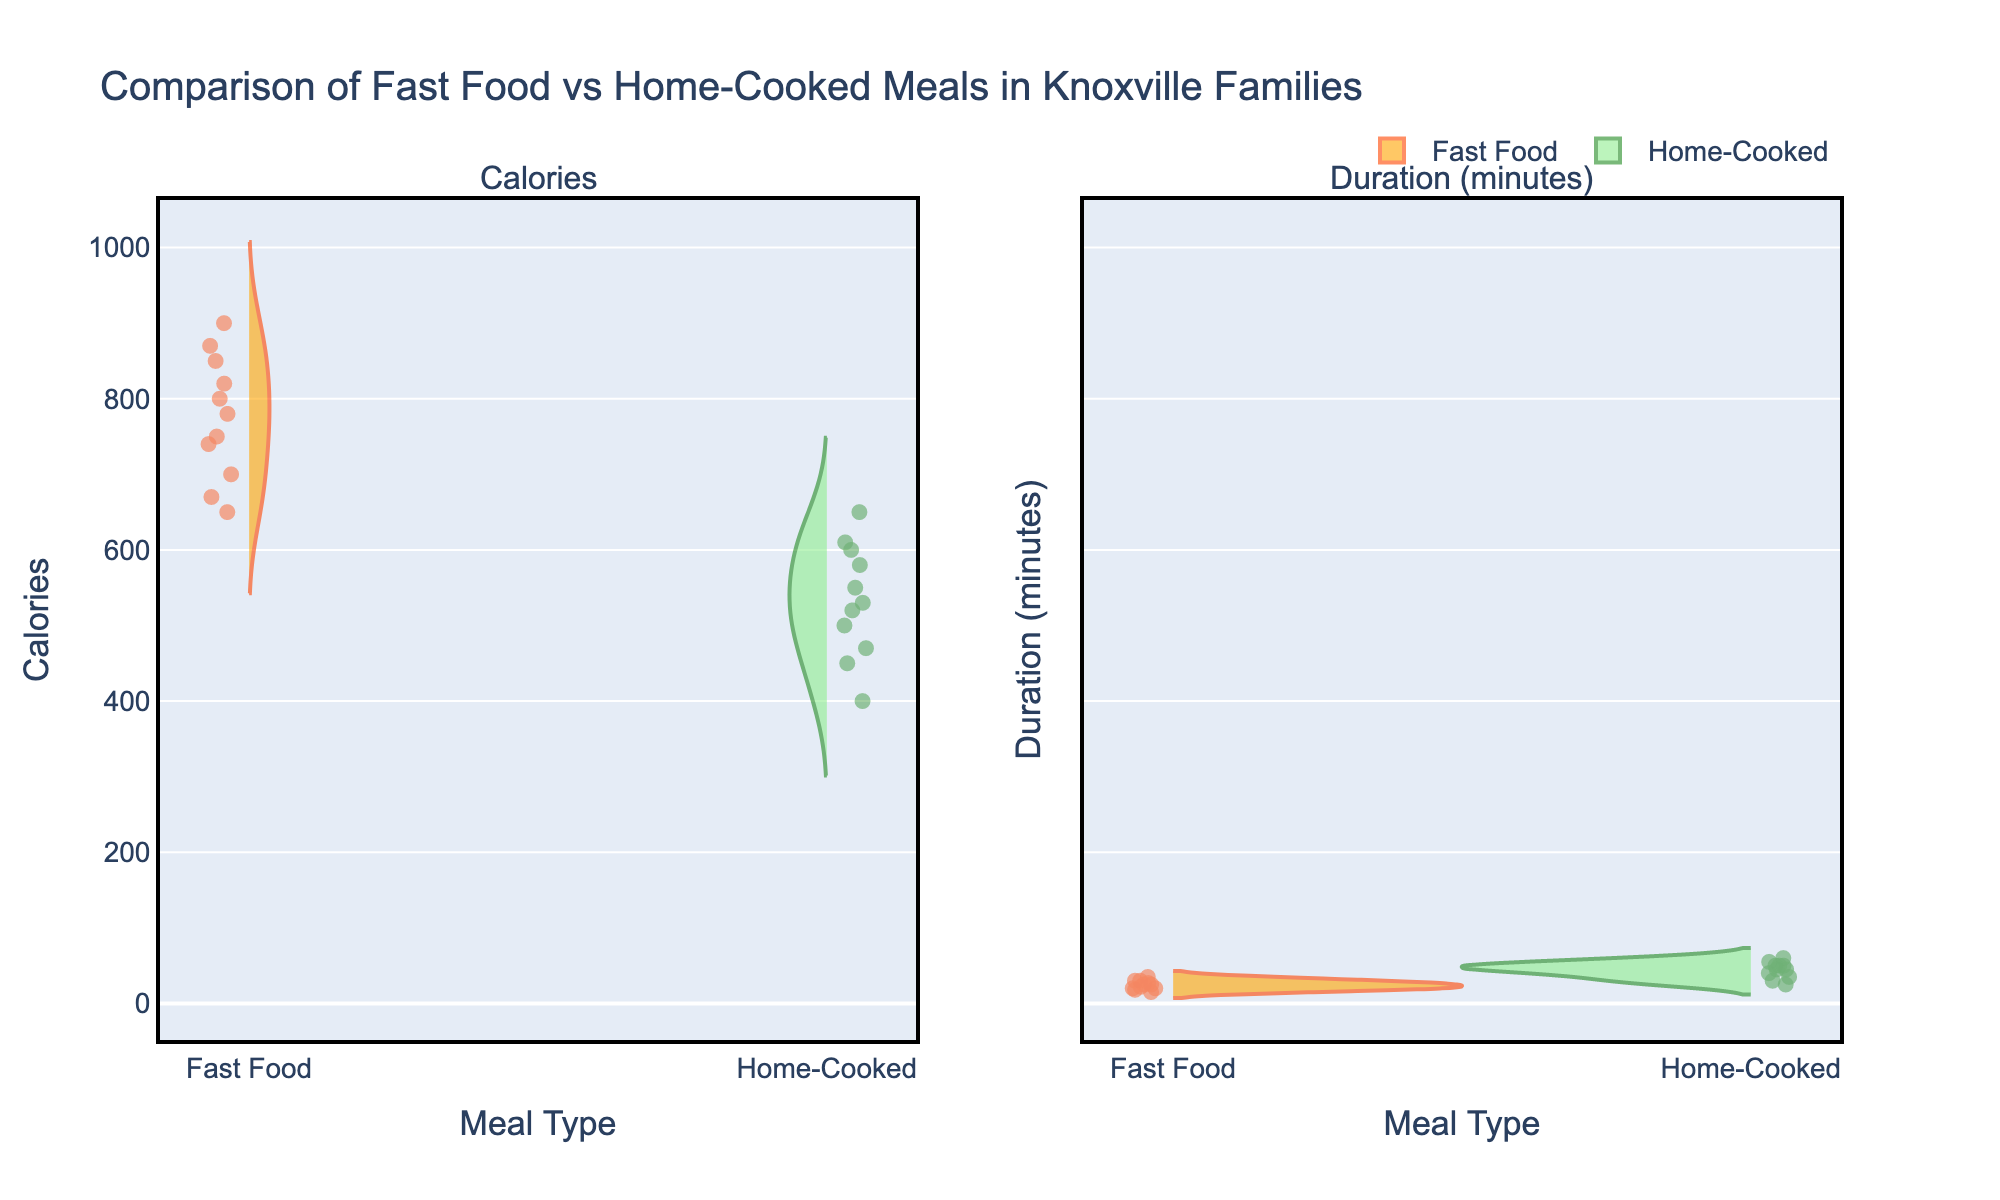What's the title of the chart? The title of the chart is displayed at the top of the figure. The text reads: "Comparison of Fast Food vs Home-Cooked Meals in Knoxville Families"
Answer: Comparison of Fast Food vs Home-Cooked Meals in Knoxville Families What are the two categories compared in the chart? The x-axis labels on both subplots indicate two categories being compared, which are "Fast Food" and "Home-Cooked".
Answer: Fast Food and Home-Cooked Which meal type generally takes longer to prepare based on the duration shown in the chart? On the Duration (minutes) subplot, the distribution of "Home-Cooked" meals is generally higher and more spread out, indicating that these meals take longer to prepare compared to "Fast Food" meals, which are more compactly distributed at lower durations.
Answer: Home-Cooked What is the color used for the "Fast Food" category in the chart? The color for "Fast Food" in both subplots is indicated by the violin plots and points; they are in orangered and orange colors.
Answer: Orange In which meal type, "Fast Food" or "Home-Cooked", does the maximum calories peak appear higher? By comparing the peaks of the calories distribution in both violins, the "Fast Food" category generally has a higher maximum peak, with values reaching up to 900 calories, while "Home-Cooked" meals rarely exceed 650 calories.
Answer: Fast Food How many data points are there for "Fast Food" in the Calories subplot? The individual points on the "Fast Food" side of the Calories subplot can be counted. There are 8 points represented.
Answer: 8 For which meal type does the average duration appear longer? Observing the spread and density of the duration values, "Home-Cooked" meals tend to have a higher average duration, as indicated by more concentrated points and a wider spread towards longer durations.
Answer: Home-Cooked Which meal type has more variance in calories? By comparing the spread of the two violins in the Calories subplot, the "Fast Food" category shows more variance in calories, as it has a wider distribution ranging from approximately 650 to 900 calories compared to "Home-Cooked".
Answer: Fast Food Is there a distinct difference in calorie distribution between adults and children for fast food meals? The individual points representing "Fast Food" calories for both adults and children can be observed. Children tend to have slightly lower calorie values while adults show a wider range and higher peaks, suggesting a measurable difference.
Answer: Yes 